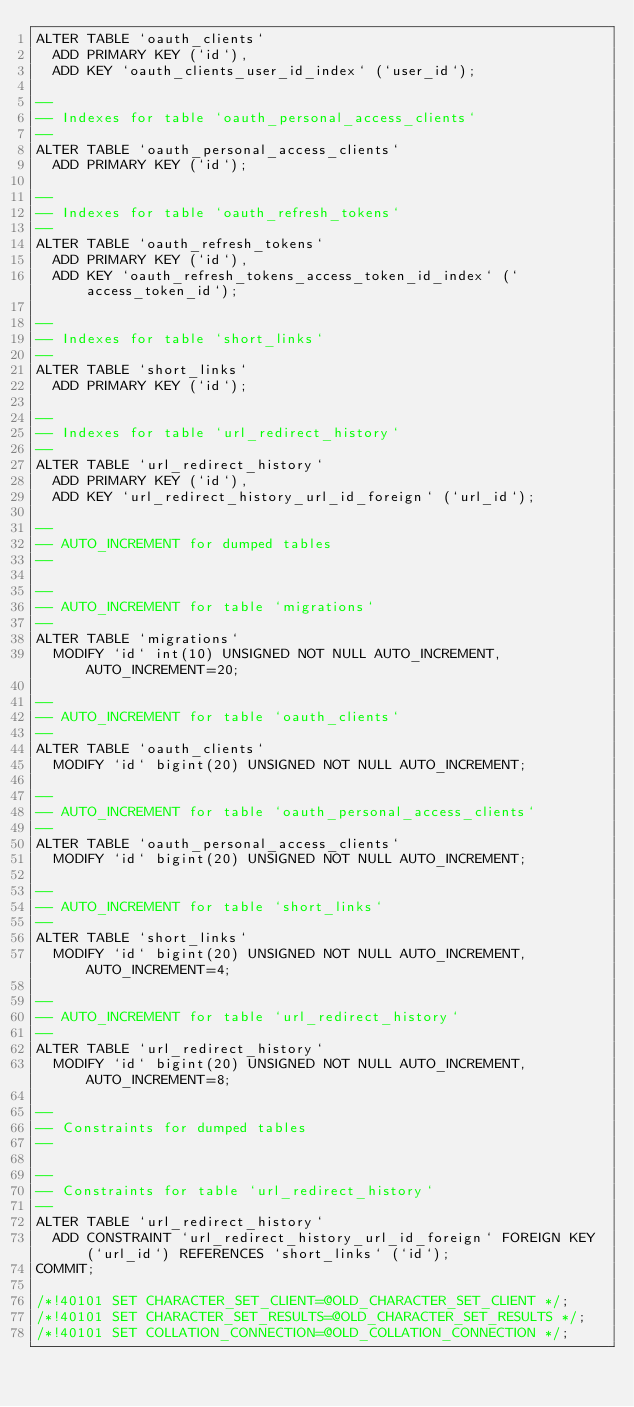<code> <loc_0><loc_0><loc_500><loc_500><_SQL_>ALTER TABLE `oauth_clients`
  ADD PRIMARY KEY (`id`),
  ADD KEY `oauth_clients_user_id_index` (`user_id`);

--
-- Indexes for table `oauth_personal_access_clients`
--
ALTER TABLE `oauth_personal_access_clients`
  ADD PRIMARY KEY (`id`);

--
-- Indexes for table `oauth_refresh_tokens`
--
ALTER TABLE `oauth_refresh_tokens`
  ADD PRIMARY KEY (`id`),
  ADD KEY `oauth_refresh_tokens_access_token_id_index` (`access_token_id`);

--
-- Indexes for table `short_links`
--
ALTER TABLE `short_links`
  ADD PRIMARY KEY (`id`);

--
-- Indexes for table `url_redirect_history`
--
ALTER TABLE `url_redirect_history`
  ADD PRIMARY KEY (`id`),
  ADD KEY `url_redirect_history_url_id_foreign` (`url_id`);

--
-- AUTO_INCREMENT for dumped tables
--

--
-- AUTO_INCREMENT for table `migrations`
--
ALTER TABLE `migrations`
  MODIFY `id` int(10) UNSIGNED NOT NULL AUTO_INCREMENT, AUTO_INCREMENT=20;

--
-- AUTO_INCREMENT for table `oauth_clients`
--
ALTER TABLE `oauth_clients`
  MODIFY `id` bigint(20) UNSIGNED NOT NULL AUTO_INCREMENT;

--
-- AUTO_INCREMENT for table `oauth_personal_access_clients`
--
ALTER TABLE `oauth_personal_access_clients`
  MODIFY `id` bigint(20) UNSIGNED NOT NULL AUTO_INCREMENT;

--
-- AUTO_INCREMENT for table `short_links`
--
ALTER TABLE `short_links`
  MODIFY `id` bigint(20) UNSIGNED NOT NULL AUTO_INCREMENT, AUTO_INCREMENT=4;

--
-- AUTO_INCREMENT for table `url_redirect_history`
--
ALTER TABLE `url_redirect_history`
  MODIFY `id` bigint(20) UNSIGNED NOT NULL AUTO_INCREMENT, AUTO_INCREMENT=8;

--
-- Constraints for dumped tables
--

--
-- Constraints for table `url_redirect_history`
--
ALTER TABLE `url_redirect_history`
  ADD CONSTRAINT `url_redirect_history_url_id_foreign` FOREIGN KEY (`url_id`) REFERENCES `short_links` (`id`);
COMMIT;

/*!40101 SET CHARACTER_SET_CLIENT=@OLD_CHARACTER_SET_CLIENT */;
/*!40101 SET CHARACTER_SET_RESULTS=@OLD_CHARACTER_SET_RESULTS */;
/*!40101 SET COLLATION_CONNECTION=@OLD_COLLATION_CONNECTION */;
</code> 